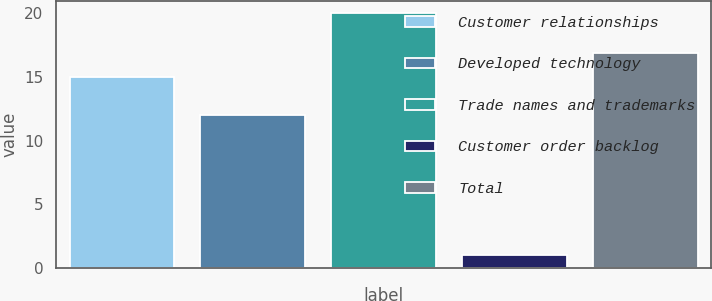<chart> <loc_0><loc_0><loc_500><loc_500><bar_chart><fcel>Customer relationships<fcel>Developed technology<fcel>Trade names and trademarks<fcel>Customer order backlog<fcel>Total<nl><fcel>15<fcel>12<fcel>20<fcel>1<fcel>16.9<nl></chart> 